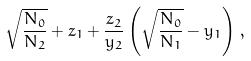Convert formula to latex. <formula><loc_0><loc_0><loc_500><loc_500>\sqrt { \frac { N _ { 0 } } { N _ { 2 } } } + z _ { 1 } + \frac { z _ { 2 } } { y _ { 2 } } \left ( \sqrt { \frac { N _ { 0 } } { N _ { 1 } } } - y _ { 1 } \right ) \, ,</formula> 